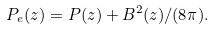Convert formula to latex. <formula><loc_0><loc_0><loc_500><loc_500>P _ { e } ( z ) = P ( z ) + B ^ { 2 } ( z ) / ( 8 \pi ) .</formula> 